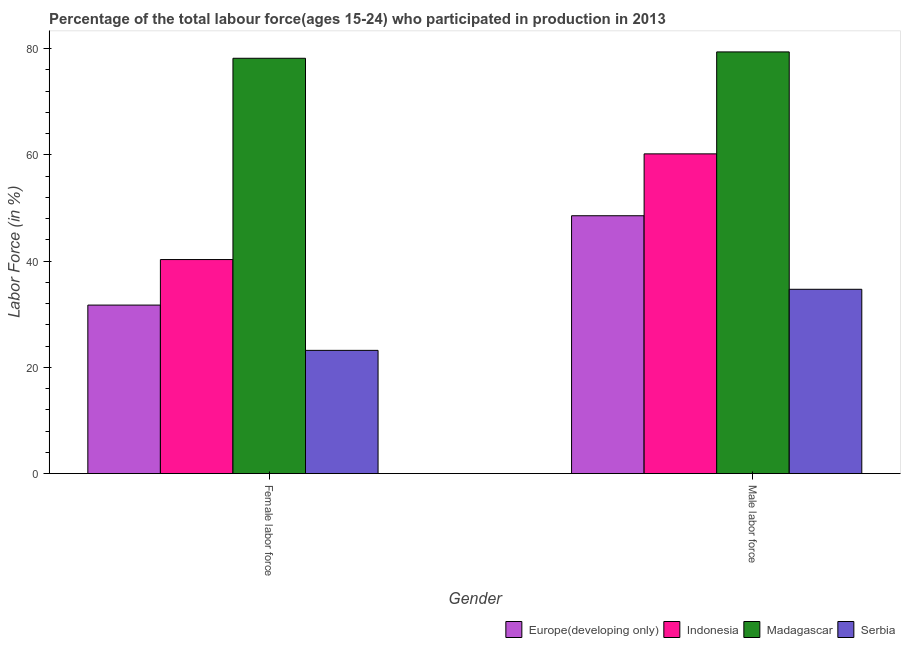How many different coloured bars are there?
Your response must be concise. 4. How many groups of bars are there?
Provide a short and direct response. 2. Are the number of bars per tick equal to the number of legend labels?
Offer a very short reply. Yes. Are the number of bars on each tick of the X-axis equal?
Give a very brief answer. Yes. What is the label of the 2nd group of bars from the left?
Your answer should be very brief. Male labor force. What is the percentage of female labor force in Serbia?
Your answer should be compact. 23.2. Across all countries, what is the maximum percentage of female labor force?
Give a very brief answer. 78.2. Across all countries, what is the minimum percentage of male labour force?
Offer a very short reply. 34.7. In which country was the percentage of male labour force maximum?
Ensure brevity in your answer.  Madagascar. In which country was the percentage of male labour force minimum?
Your response must be concise. Serbia. What is the total percentage of female labor force in the graph?
Your response must be concise. 173.43. What is the difference between the percentage of female labor force in Indonesia and that in Madagascar?
Offer a very short reply. -37.9. What is the difference between the percentage of male labour force in Serbia and the percentage of female labor force in Madagascar?
Your answer should be very brief. -43.5. What is the average percentage of female labor force per country?
Give a very brief answer. 43.36. What is the difference between the percentage of male labour force and percentage of female labor force in Serbia?
Your answer should be compact. 11.5. What is the ratio of the percentage of male labour force in Madagascar to that in Serbia?
Ensure brevity in your answer.  2.29. What does the 4th bar from the left in Male labor force represents?
Your answer should be compact. Serbia. What does the 1st bar from the right in Male labor force represents?
Ensure brevity in your answer.  Serbia. Are the values on the major ticks of Y-axis written in scientific E-notation?
Make the answer very short. No. Where does the legend appear in the graph?
Your response must be concise. Bottom right. How many legend labels are there?
Offer a very short reply. 4. What is the title of the graph?
Provide a succinct answer. Percentage of the total labour force(ages 15-24) who participated in production in 2013. Does "Guam" appear as one of the legend labels in the graph?
Ensure brevity in your answer.  No. What is the Labor Force (in %) of Europe(developing only) in Female labor force?
Give a very brief answer. 31.73. What is the Labor Force (in %) in Indonesia in Female labor force?
Your answer should be compact. 40.3. What is the Labor Force (in %) of Madagascar in Female labor force?
Ensure brevity in your answer.  78.2. What is the Labor Force (in %) of Serbia in Female labor force?
Keep it short and to the point. 23.2. What is the Labor Force (in %) of Europe(developing only) in Male labor force?
Ensure brevity in your answer.  48.55. What is the Labor Force (in %) in Indonesia in Male labor force?
Ensure brevity in your answer.  60.2. What is the Labor Force (in %) of Madagascar in Male labor force?
Offer a terse response. 79.4. What is the Labor Force (in %) in Serbia in Male labor force?
Provide a succinct answer. 34.7. Across all Gender, what is the maximum Labor Force (in %) of Europe(developing only)?
Keep it short and to the point. 48.55. Across all Gender, what is the maximum Labor Force (in %) of Indonesia?
Your answer should be compact. 60.2. Across all Gender, what is the maximum Labor Force (in %) of Madagascar?
Ensure brevity in your answer.  79.4. Across all Gender, what is the maximum Labor Force (in %) in Serbia?
Offer a very short reply. 34.7. Across all Gender, what is the minimum Labor Force (in %) of Europe(developing only)?
Your answer should be very brief. 31.73. Across all Gender, what is the minimum Labor Force (in %) in Indonesia?
Your answer should be very brief. 40.3. Across all Gender, what is the minimum Labor Force (in %) in Madagascar?
Your answer should be compact. 78.2. Across all Gender, what is the minimum Labor Force (in %) in Serbia?
Ensure brevity in your answer.  23.2. What is the total Labor Force (in %) of Europe(developing only) in the graph?
Your answer should be very brief. 80.28. What is the total Labor Force (in %) in Indonesia in the graph?
Keep it short and to the point. 100.5. What is the total Labor Force (in %) of Madagascar in the graph?
Keep it short and to the point. 157.6. What is the total Labor Force (in %) in Serbia in the graph?
Make the answer very short. 57.9. What is the difference between the Labor Force (in %) of Europe(developing only) in Female labor force and that in Male labor force?
Your answer should be very brief. -16.82. What is the difference between the Labor Force (in %) of Indonesia in Female labor force and that in Male labor force?
Give a very brief answer. -19.9. What is the difference between the Labor Force (in %) in Serbia in Female labor force and that in Male labor force?
Keep it short and to the point. -11.5. What is the difference between the Labor Force (in %) in Europe(developing only) in Female labor force and the Labor Force (in %) in Indonesia in Male labor force?
Keep it short and to the point. -28.47. What is the difference between the Labor Force (in %) of Europe(developing only) in Female labor force and the Labor Force (in %) of Madagascar in Male labor force?
Your answer should be compact. -47.67. What is the difference between the Labor Force (in %) in Europe(developing only) in Female labor force and the Labor Force (in %) in Serbia in Male labor force?
Your answer should be very brief. -2.97. What is the difference between the Labor Force (in %) in Indonesia in Female labor force and the Labor Force (in %) in Madagascar in Male labor force?
Give a very brief answer. -39.1. What is the difference between the Labor Force (in %) in Madagascar in Female labor force and the Labor Force (in %) in Serbia in Male labor force?
Your answer should be compact. 43.5. What is the average Labor Force (in %) of Europe(developing only) per Gender?
Offer a very short reply. 40.14. What is the average Labor Force (in %) in Indonesia per Gender?
Provide a succinct answer. 50.25. What is the average Labor Force (in %) in Madagascar per Gender?
Provide a short and direct response. 78.8. What is the average Labor Force (in %) of Serbia per Gender?
Your response must be concise. 28.95. What is the difference between the Labor Force (in %) of Europe(developing only) and Labor Force (in %) of Indonesia in Female labor force?
Your response must be concise. -8.57. What is the difference between the Labor Force (in %) of Europe(developing only) and Labor Force (in %) of Madagascar in Female labor force?
Provide a succinct answer. -46.47. What is the difference between the Labor Force (in %) of Europe(developing only) and Labor Force (in %) of Serbia in Female labor force?
Ensure brevity in your answer.  8.53. What is the difference between the Labor Force (in %) of Indonesia and Labor Force (in %) of Madagascar in Female labor force?
Your answer should be compact. -37.9. What is the difference between the Labor Force (in %) of Indonesia and Labor Force (in %) of Serbia in Female labor force?
Make the answer very short. 17.1. What is the difference between the Labor Force (in %) in Madagascar and Labor Force (in %) in Serbia in Female labor force?
Keep it short and to the point. 55. What is the difference between the Labor Force (in %) of Europe(developing only) and Labor Force (in %) of Indonesia in Male labor force?
Provide a short and direct response. -11.65. What is the difference between the Labor Force (in %) of Europe(developing only) and Labor Force (in %) of Madagascar in Male labor force?
Your answer should be compact. -30.85. What is the difference between the Labor Force (in %) in Europe(developing only) and Labor Force (in %) in Serbia in Male labor force?
Keep it short and to the point. 13.85. What is the difference between the Labor Force (in %) of Indonesia and Labor Force (in %) of Madagascar in Male labor force?
Offer a terse response. -19.2. What is the difference between the Labor Force (in %) of Madagascar and Labor Force (in %) of Serbia in Male labor force?
Provide a short and direct response. 44.7. What is the ratio of the Labor Force (in %) of Europe(developing only) in Female labor force to that in Male labor force?
Provide a succinct answer. 0.65. What is the ratio of the Labor Force (in %) of Indonesia in Female labor force to that in Male labor force?
Offer a terse response. 0.67. What is the ratio of the Labor Force (in %) of Madagascar in Female labor force to that in Male labor force?
Your response must be concise. 0.98. What is the ratio of the Labor Force (in %) of Serbia in Female labor force to that in Male labor force?
Give a very brief answer. 0.67. What is the difference between the highest and the second highest Labor Force (in %) of Europe(developing only)?
Offer a very short reply. 16.82. What is the difference between the highest and the second highest Labor Force (in %) of Indonesia?
Your answer should be very brief. 19.9. What is the difference between the highest and the second highest Labor Force (in %) of Madagascar?
Your answer should be compact. 1.2. What is the difference between the highest and the lowest Labor Force (in %) in Europe(developing only)?
Your response must be concise. 16.82. What is the difference between the highest and the lowest Labor Force (in %) in Madagascar?
Offer a terse response. 1.2. 